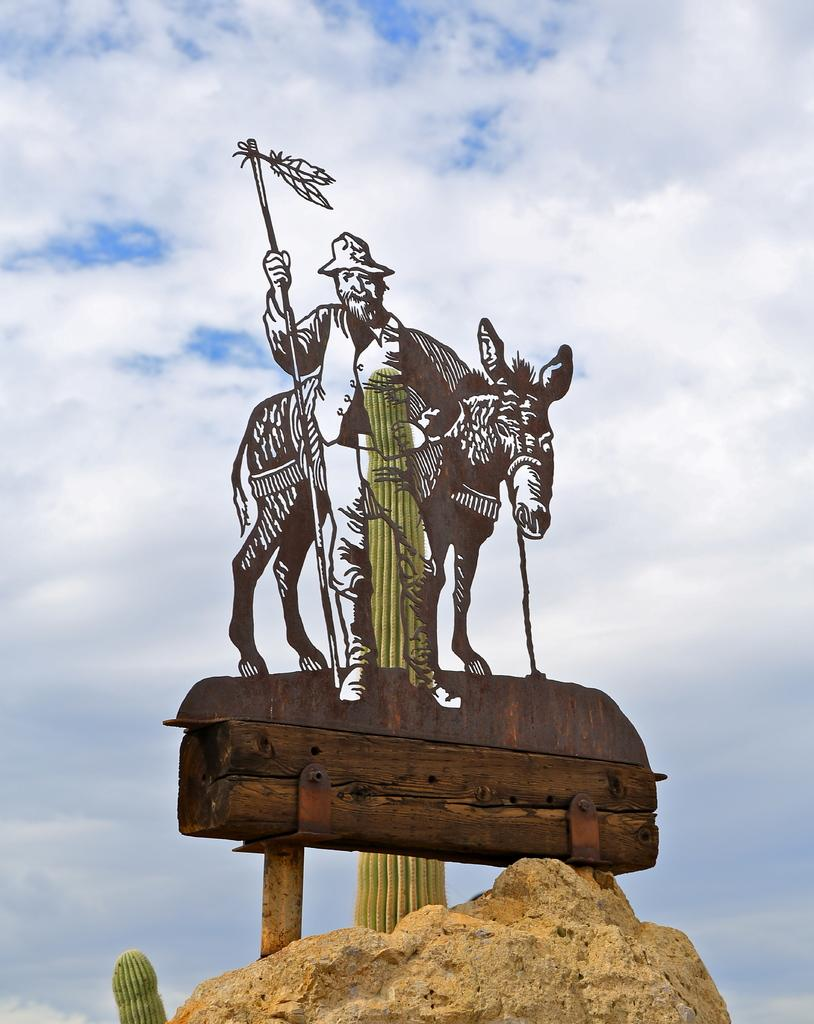What is depicted on the board in the image? There is a person and a horse above a rock on the board in the image. What is the condition of the sky in the background? The sky is cloudy in the background. What type of vegetation can be seen in the background? Cactus plants are present in the background. What type of stitch is used to create the person and horse on the board? The image does not provide information about the stitching technique used to create the person and horse on the board. What is the title of the artwork displayed on the board? The image does not provide information about the title of the artwork displayed on the board. 